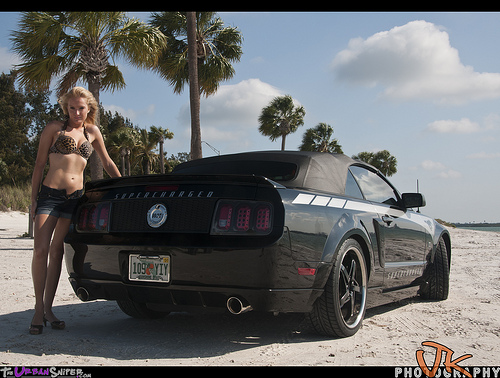<image>
Is the car to the left of the woman? No. The car is not to the left of the woman. From this viewpoint, they have a different horizontal relationship. 